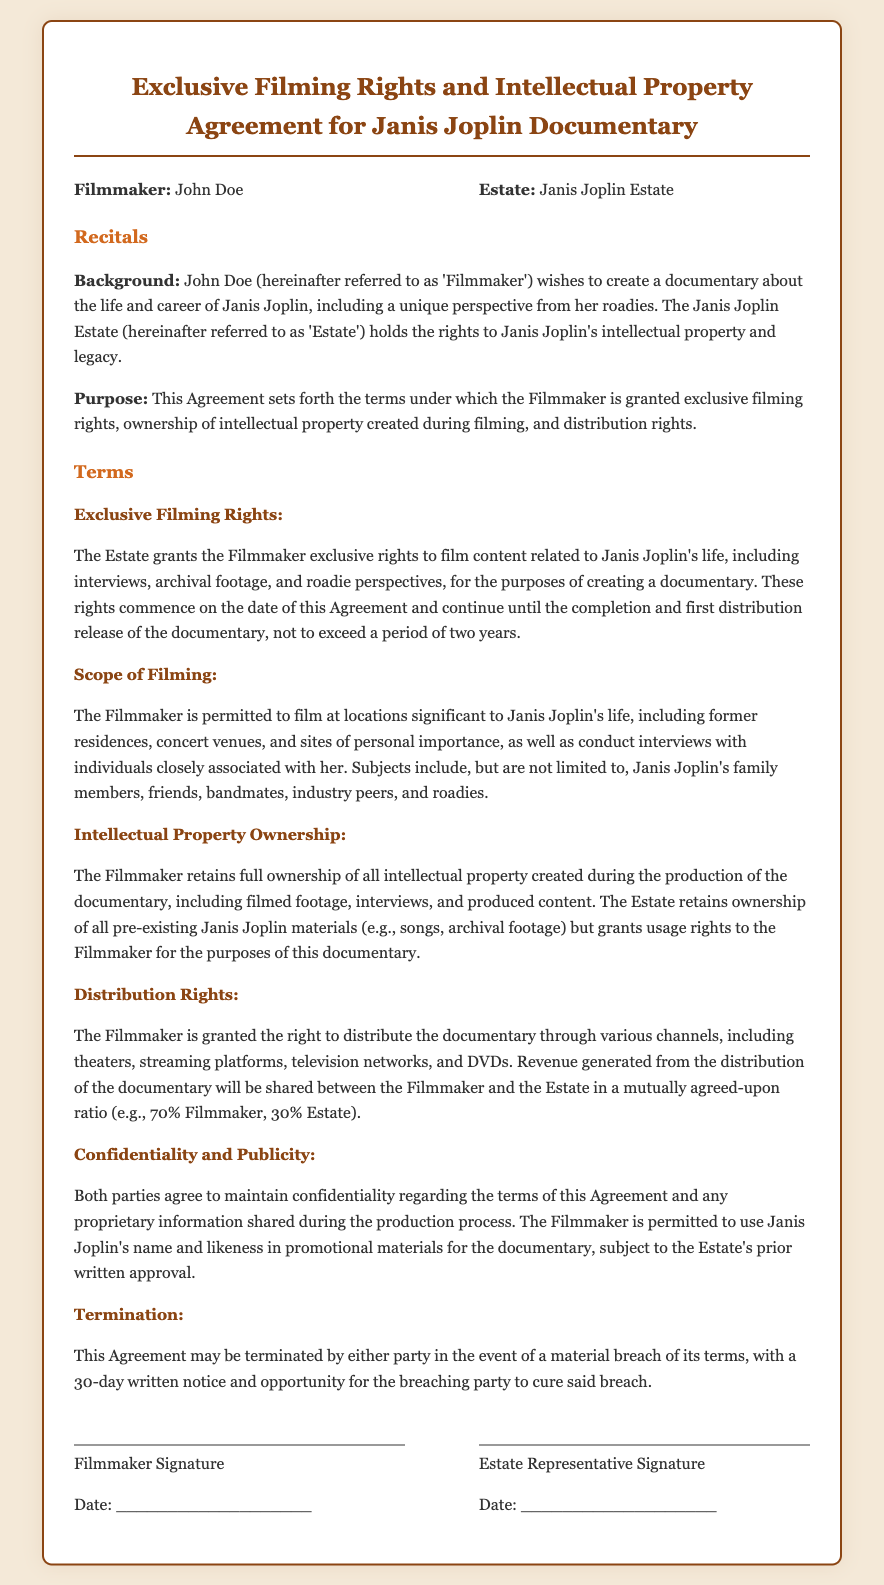what is the name of the filmmaker? The filmmaker is identified as John Doe in the document.
Answer: John Doe who holds the rights to Janis Joplin's intellectual property? The document states that the Janis Joplin Estate holds the rights to her intellectual property.
Answer: Janis Joplin Estate what is the duration of the exclusive filming rights? The exclusive filming rights are effective until the completion and first distribution release of the documentary, not to exceed a period of two years.
Answer: two years which individuals are permitted for interviews? The document lists family members, friends, bandmates, industry peers, and roadies as subjects for interviews.
Answer: family members, friends, bandmates, industry peers, and roadies what percentage of revenue is shared with the Estate? The revenue generated from the documentary distribution will be shared in a mutually agreed-upon ratio, specifically mentioned as 30% for the Estate.
Answer: 30% what must happen for either party to terminate the agreement? The agreement can be terminated in the event of a material breach of its terms, requiring a 30-day written notice.
Answer: material breach what type of information must remain confidential? Both parties agree to maintain confidentiality regarding the terms of the Agreement and proprietary information shared during the production process.
Answer: terms of this Agreement and proprietary information what type of materials can the Filmmaker use for promotional purposes? The Filmmaker is permitted to use Janis Joplin's name and likeness in promotional materials.
Answer: name and likeness 